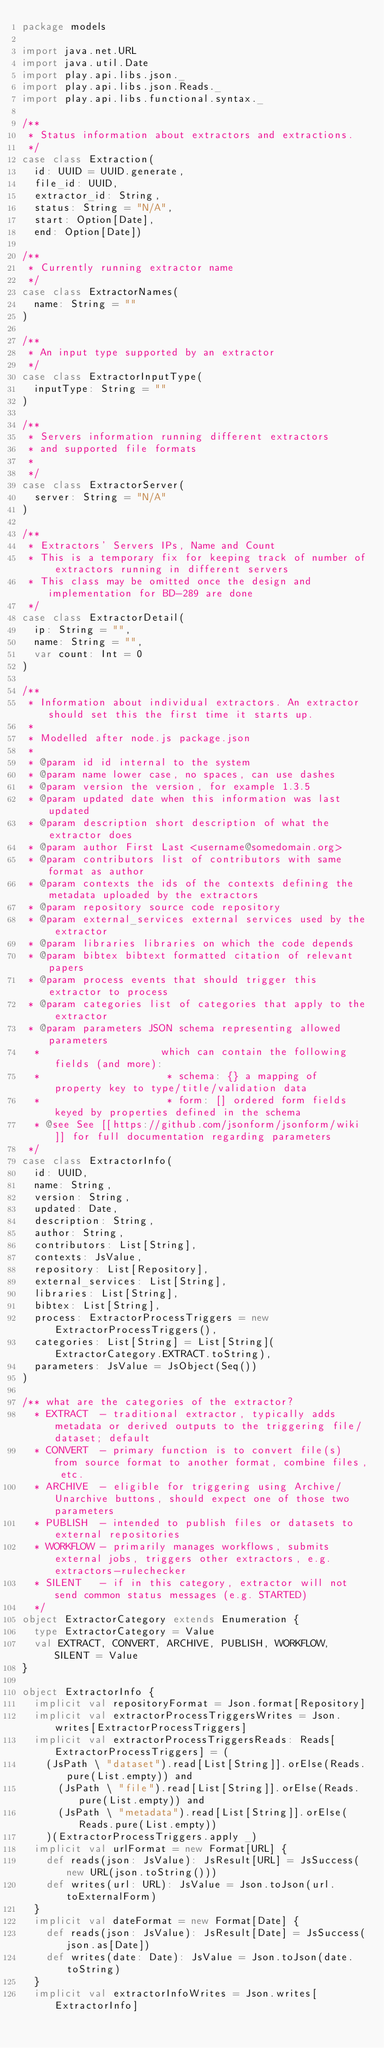<code> <loc_0><loc_0><loc_500><loc_500><_Scala_>package models

import java.net.URL
import java.util.Date
import play.api.libs.json._
import play.api.libs.json.Reads._
import play.api.libs.functional.syntax._

/**
 * Status information about extractors and extractions.
 */
case class Extraction(
  id: UUID = UUID.generate,
  file_id: UUID,
  extractor_id: String,
  status: String = "N/A",
  start: Option[Date],
  end: Option[Date])

/**
 * Currently running extractor name
 */
case class ExtractorNames(
  name: String = ""
)

/**
 * An input type supported by an extractor
 */
case class ExtractorInputType(
  inputType: String = ""
)

/**
 * Servers information running different extractors
 * and supported file formats
 *
 */
case class ExtractorServer(
  server: String = "N/A"
)

/**
 * Extractors' Servers IPs, Name and Count
 * This is a temporary fix for keeping track of number of extractors running in different servers
 * This class may be omitted once the design and implementation for BD-289 are done
 */
case class ExtractorDetail(
  ip: String = "",
  name: String = "",
  var count: Int = 0
)

/**
 * Information about individual extractors. An extractor should set this the first time it starts up.
 *
 * Modelled after node.js package.json
 *
 * @param id id internal to the system
 * @param name lower case, no spaces, can use dashes
 * @param version the version, for example 1.3.5
 * @param updated date when this information was last updated
 * @param description short description of what the extractor does
 * @param author First Last <username@somedomain.org>
 * @param contributors list of contributors with same format as author
 * @param contexts the ids of the contexts defining the metadata uploaded by the extractors
 * @param repository source code repository
 * @param external_services external services used by the extractor
 * @param libraries libraries on which the code depends
 * @param bibtex bibtext formatted citation of relevant papers
 * @param process events that should trigger this extractor to process
 * @param categories list of categories that apply to the extractor
 * @param parameters JSON schema representing allowed parameters
  *                    which can contain the following fields (and more):
  *                     * schema: {} a mapping of property key to type/title/validation data
  *                     * form: [] ordered form fields keyed by properties defined in the schema
  * @see See [[https://github.com/jsonform/jsonform/wiki]] for full documentation regarding parameters
 */
case class ExtractorInfo(
  id: UUID,
  name: String,
  version: String,
  updated: Date,
  description: String,
  author: String,
  contributors: List[String],
  contexts: JsValue,
  repository: List[Repository],
  external_services: List[String],
  libraries: List[String],
  bibtex: List[String],
  process: ExtractorProcessTriggers = new ExtractorProcessTriggers(),
  categories: List[String] = List[String](ExtractorCategory.EXTRACT.toString),
  parameters: JsValue = JsObject(Seq())
)

/** what are the categories of the extractor?
  * EXTRACT  - traditional extractor, typically adds metadata or derived outputs to the triggering file/dataset; default
  * CONVERT  - primary function is to convert file(s) from source format to another format, combine files, etc.
  * ARCHIVE  - eligible for triggering using Archive/Unarchive buttons, should expect one of those two parameters
  * PUBLISH  - intended to publish files or datasets to external repositories
  * WORKFLOW - primarily manages workflows, submits external jobs, triggers other extractors, e.g. extractors-rulechecker
  * SILENT   - if in this category, extractor will not send common status messages (e.g. STARTED)
  */
object ExtractorCategory extends Enumeration {
  type ExtractorCategory = Value
  val EXTRACT, CONVERT, ARCHIVE, PUBLISH, WORKFLOW, SILENT = Value
}

object ExtractorInfo {
  implicit val repositoryFormat = Json.format[Repository]
  implicit val extractorProcessTriggersWrites = Json.writes[ExtractorProcessTriggers]
  implicit val extractorProcessTriggersReads: Reads[ExtractorProcessTriggers] = (
    (JsPath \ "dataset").read[List[String]].orElse(Reads.pure(List.empty)) and
      (JsPath \ "file").read[List[String]].orElse(Reads.pure(List.empty)) and
      (JsPath \ "metadata").read[List[String]].orElse(Reads.pure(List.empty))
    )(ExtractorProcessTriggers.apply _)
  implicit val urlFormat = new Format[URL] {
    def reads(json: JsValue): JsResult[URL] = JsSuccess(new URL(json.toString()))
    def writes(url: URL): JsValue = Json.toJson(url.toExternalForm)
  }
  implicit val dateFormat = new Format[Date] {
    def reads(json: JsValue): JsResult[Date] = JsSuccess(json.as[Date])
    def writes(date: Date): JsValue = Json.toJson(date.toString)
  }
  implicit val extractorInfoWrites = Json.writes[ExtractorInfo]</code> 